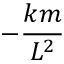<formula> <loc_0><loc_0><loc_500><loc_500>- { \frac { k m } { L ^ { 2 } } }</formula> 